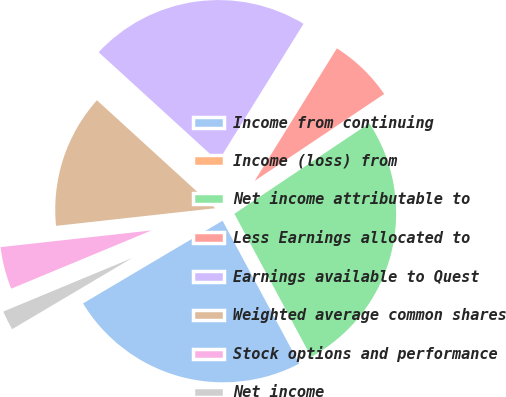Convert chart. <chart><loc_0><loc_0><loc_500><loc_500><pie_chart><fcel>Income from continuing<fcel>Income (loss) from<fcel>Net income attributable to<fcel>Less Earnings allocated to<fcel>Earnings available to Quest<fcel>Weighted average common shares<fcel>Stock options and performance<fcel>Net income<nl><fcel>24.32%<fcel>0.0%<fcel>26.57%<fcel>6.76%<fcel>22.06%<fcel>13.53%<fcel>4.51%<fcel>2.25%<nl></chart> 